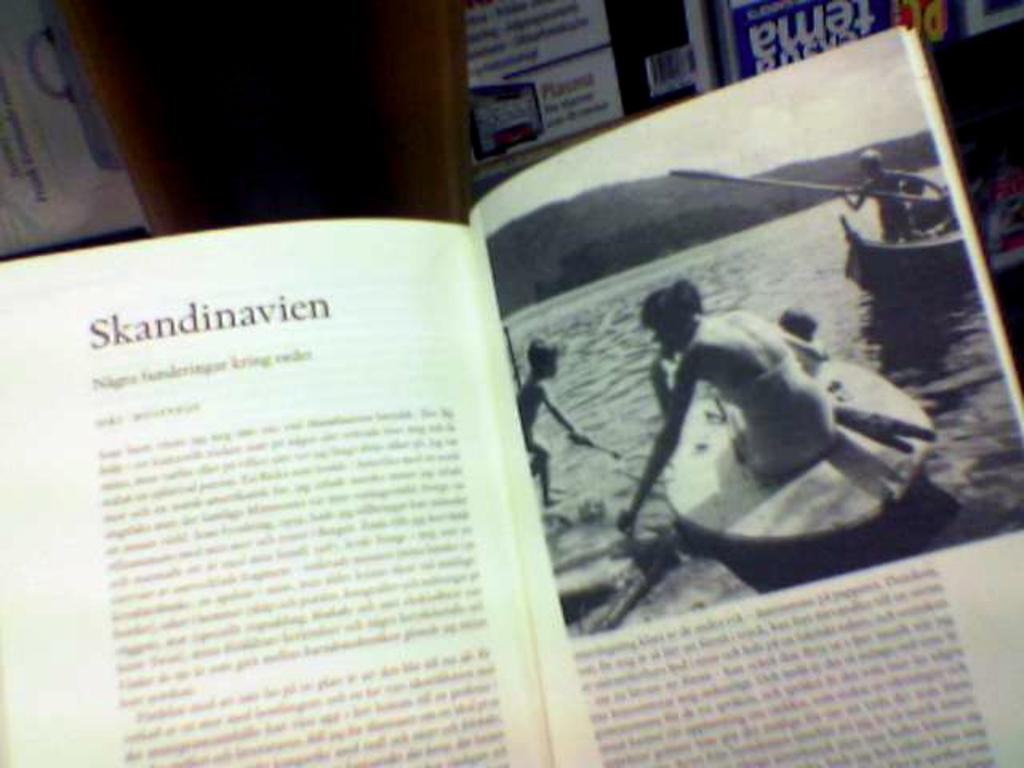<image>
Render a clear and concise summary of the photo. A book which includes a chapter titled Skandinavien as well as a photo of people in boats on a lake. 